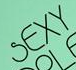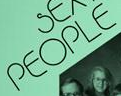What words are shown in these images in order, separated by a semicolon? SEXY; PEOPLE 